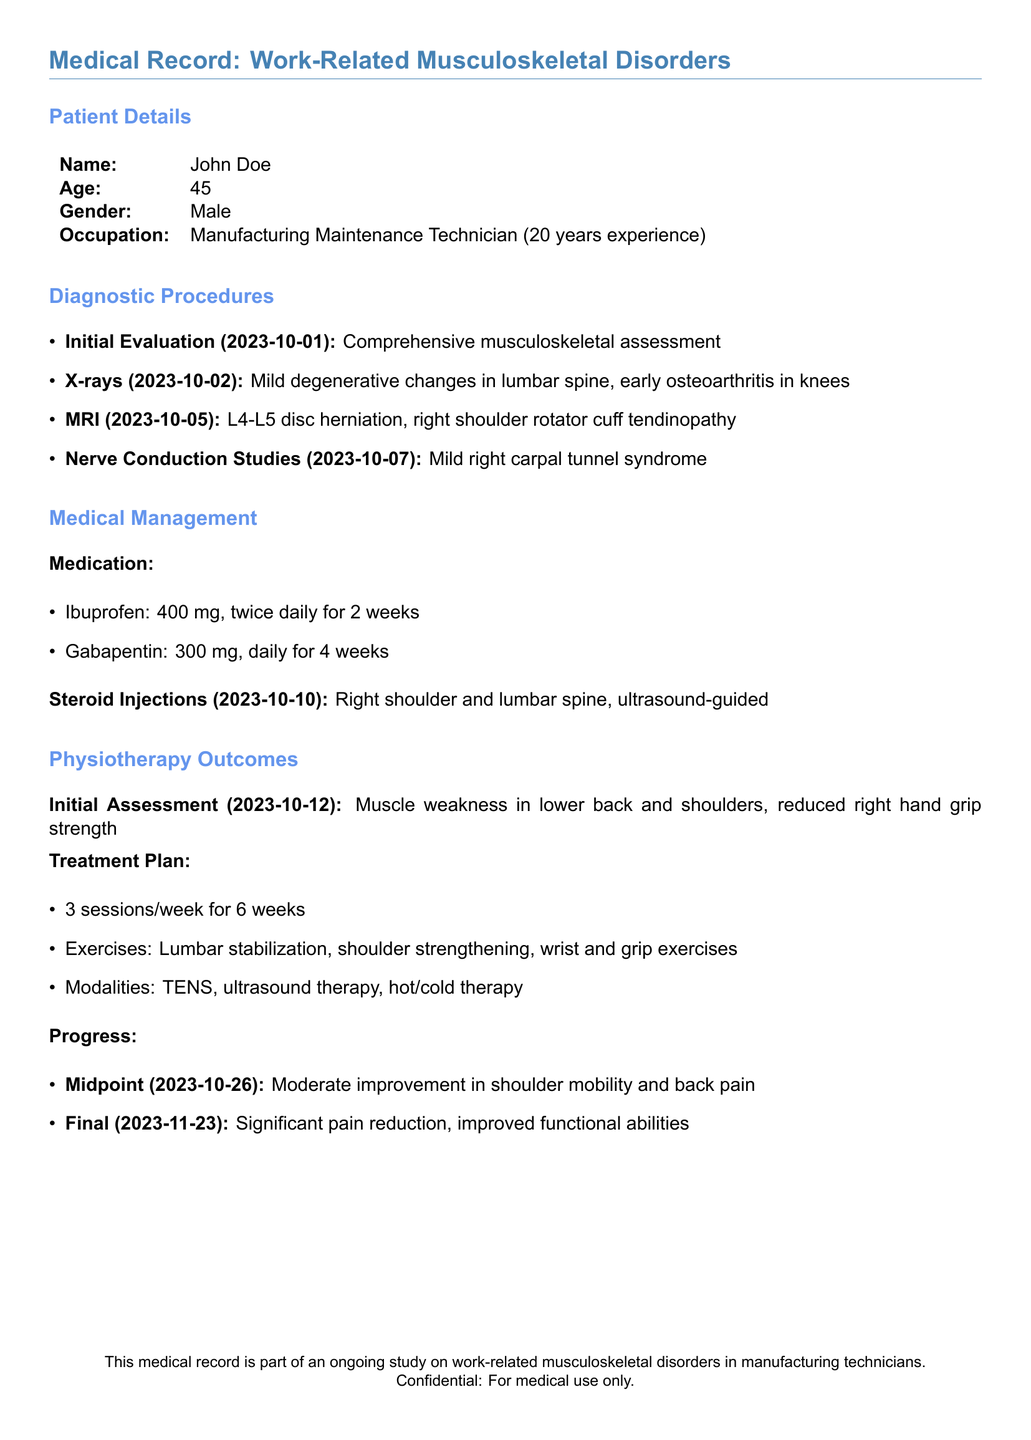What is the name of the patient? The patient's name is explicitly stated in the document as John Doe.
Answer: John Doe How old is the patient? The patient's age is provided directly in the document as 45 years old.
Answer: 45 What occupation does the patient have? The patient's occupation is listed as Manufacturing Maintenance Technician.
Answer: Manufacturing Maintenance Technician When was the initial evaluation conducted? The document specifies that the initial evaluation was performed on 2023-10-01.
Answer: 2023-10-01 What diagnosis was revealed by the MRI? The MRI results indicated L4-L5 disc herniation, which is mentioned in the document.
Answer: L4-L5 disc herniation What medication is the patient prescribed for back pain? The document lists Ibuprofen as a prescribed medication for the patient.
Answer: Ibuprofen How many physiotherapy sessions are planned per week? The treatment plan outlines that there are 3 physiotherapy sessions scheduled per week.
Answer: 3 What improvement was noted at the midpoint of treatment? The document states that there was moderate improvement in shoulder mobility and back pain at the midpoint.
Answer: Moderate improvement in shoulder mobility and back pain What type of injections did the patient receive on 2023-10-10? The document specifies that the patient received ultrasound-guided steroid injections.
Answer: Ultrasound-guided steroid injections What was the final progress noted in the treatment? The final progress report highlights significant pain reduction and improved functional abilities.
Answer: Significant pain reduction, improved functional abilities 